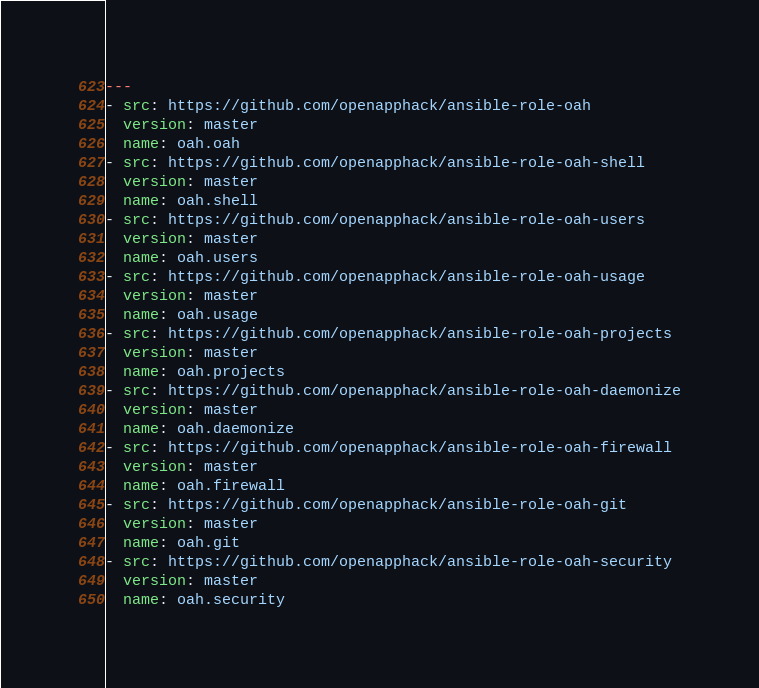Convert code to text. <code><loc_0><loc_0><loc_500><loc_500><_YAML_>---
- src: https://github.com/openapphack/ansible-role-oah
  version: master
  name: oah.oah
- src: https://github.com/openapphack/ansible-role-oah-shell
  version: master
  name: oah.shell
- src: https://github.com/openapphack/ansible-role-oah-users
  version: master
  name: oah.users
- src: https://github.com/openapphack/ansible-role-oah-usage
  version: master
  name: oah.usage
- src: https://github.com/openapphack/ansible-role-oah-projects
  version: master
  name: oah.projects
- src: https://github.com/openapphack/ansible-role-oah-daemonize
  version: master
  name: oah.daemonize
- src: https://github.com/openapphack/ansible-role-oah-firewall
  version: master
  name: oah.firewall
- src: https://github.com/openapphack/ansible-role-oah-git
  version: master
  name: oah.git
- src: https://github.com/openapphack/ansible-role-oah-security
  version: master
  name: oah.security
</code> 